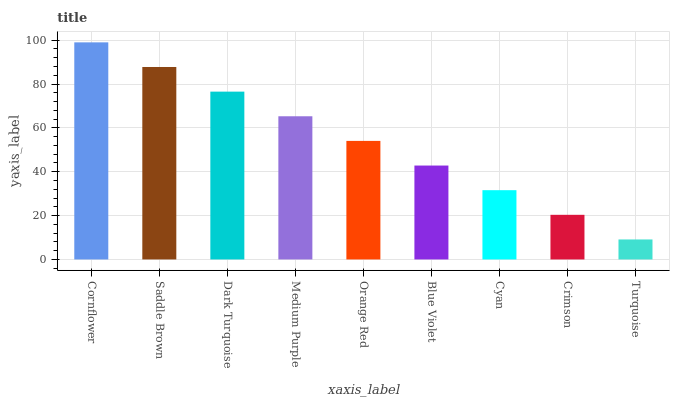Is Turquoise the minimum?
Answer yes or no. Yes. Is Cornflower the maximum?
Answer yes or no. Yes. Is Saddle Brown the minimum?
Answer yes or no. No. Is Saddle Brown the maximum?
Answer yes or no. No. Is Cornflower greater than Saddle Brown?
Answer yes or no. Yes. Is Saddle Brown less than Cornflower?
Answer yes or no. Yes. Is Saddle Brown greater than Cornflower?
Answer yes or no. No. Is Cornflower less than Saddle Brown?
Answer yes or no. No. Is Orange Red the high median?
Answer yes or no. Yes. Is Orange Red the low median?
Answer yes or no. Yes. Is Crimson the high median?
Answer yes or no. No. Is Turquoise the low median?
Answer yes or no. No. 